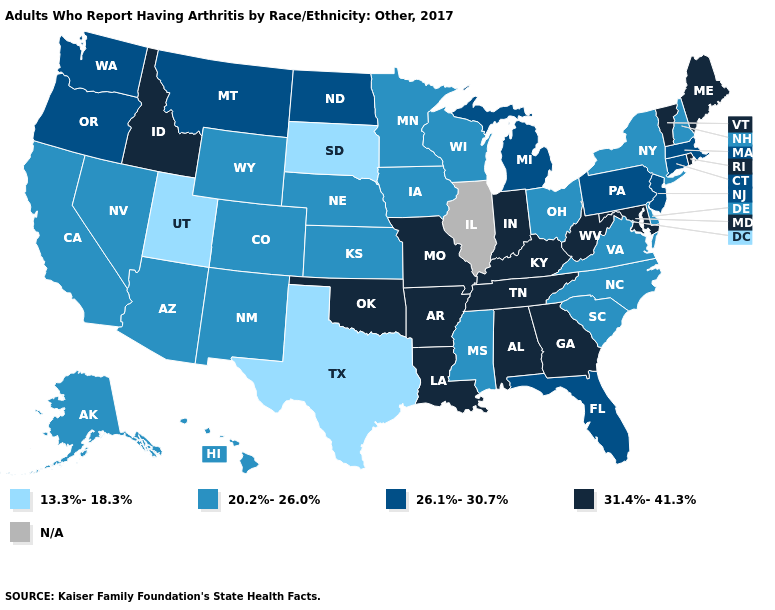Which states have the highest value in the USA?
Be succinct. Alabama, Arkansas, Georgia, Idaho, Indiana, Kentucky, Louisiana, Maine, Maryland, Missouri, Oklahoma, Rhode Island, Tennessee, Vermont, West Virginia. What is the value of New Jersey?
Answer briefly. 26.1%-30.7%. Does Missouri have the lowest value in the USA?
Short answer required. No. What is the value of Idaho?
Concise answer only. 31.4%-41.3%. Does New Hampshire have the lowest value in the Northeast?
Answer briefly. Yes. What is the highest value in states that border Colorado?
Keep it brief. 31.4%-41.3%. What is the value of South Dakota?
Concise answer only. 13.3%-18.3%. Name the states that have a value in the range N/A?
Be succinct. Illinois. What is the value of Montana?
Write a very short answer. 26.1%-30.7%. What is the value of Maine?
Answer briefly. 31.4%-41.3%. Name the states that have a value in the range N/A?
Be succinct. Illinois. Which states hav the highest value in the South?
Concise answer only. Alabama, Arkansas, Georgia, Kentucky, Louisiana, Maryland, Oklahoma, Tennessee, West Virginia. What is the highest value in the South ?
Give a very brief answer. 31.4%-41.3%. Does the first symbol in the legend represent the smallest category?
Keep it brief. Yes. 